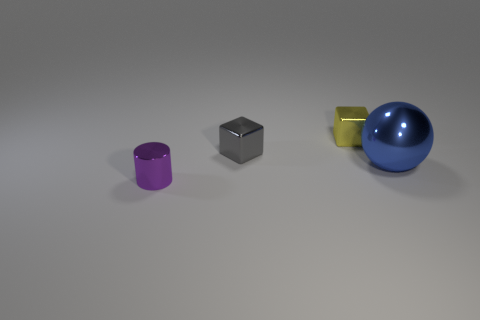How many metallic things are large gray cylinders or spheres?
Provide a succinct answer. 1. Are there any big purple shiny cubes?
Give a very brief answer. No. Do the yellow metal thing and the large blue object have the same shape?
Offer a very short reply. No. How many large things are cyan blocks or yellow metal blocks?
Give a very brief answer. 0. The large metallic object has what color?
Give a very brief answer. Blue. What is the shape of the thing that is right of the small thing right of the gray cube?
Provide a succinct answer. Sphere. Are there any gray blocks that have the same material as the small yellow thing?
Give a very brief answer. Yes. There is a blue thing in front of the gray thing; does it have the same size as the small yellow metal object?
Your response must be concise. No. What number of gray things are tiny shiny blocks or tiny matte objects?
Your response must be concise. 1. What is the material of the tiny block that is behind the tiny gray metallic cube?
Provide a succinct answer. Metal. 